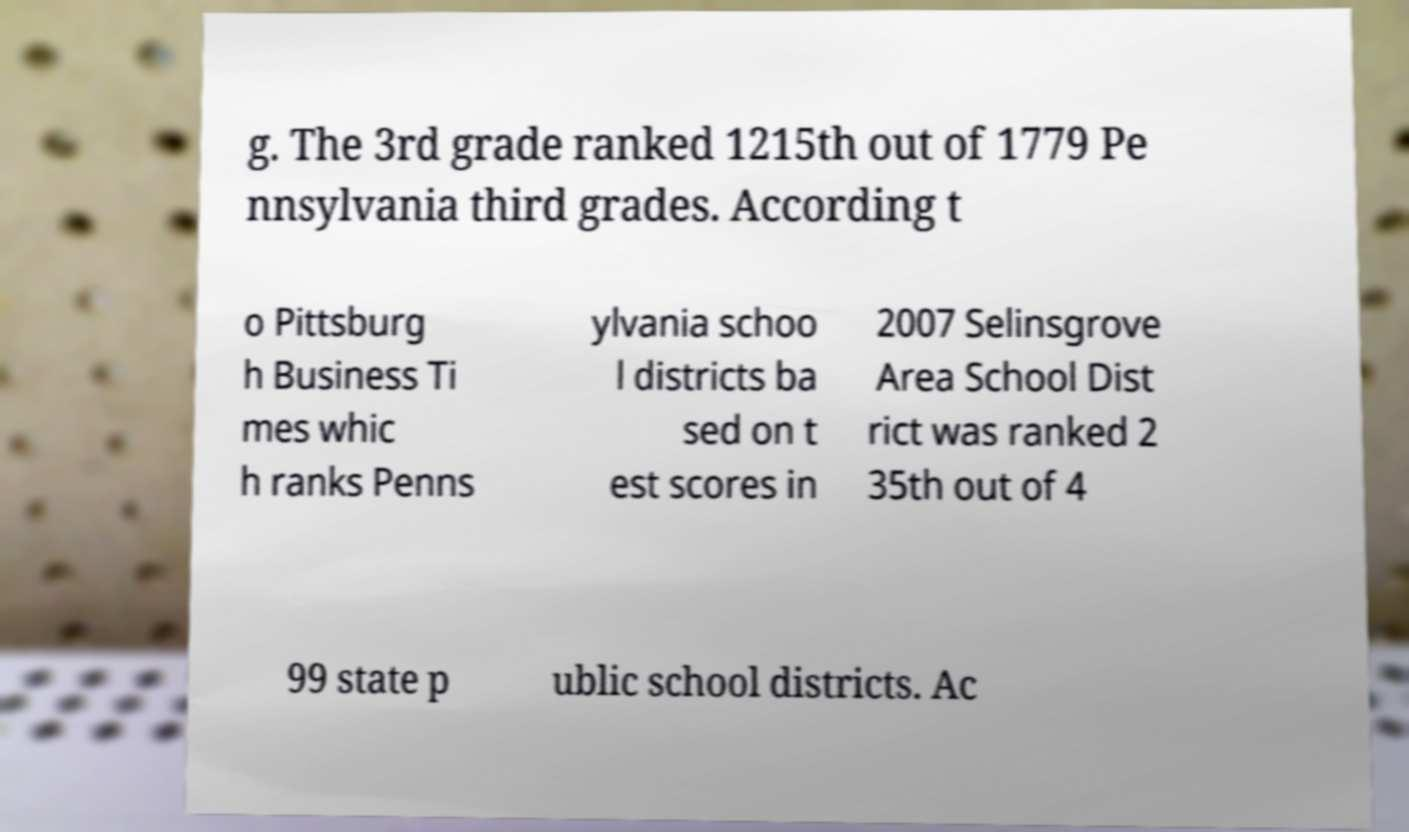Can you accurately transcribe the text from the provided image for me? g. The 3rd grade ranked 1215th out of 1779 Pe nnsylvania third grades. According t o Pittsburg h Business Ti mes whic h ranks Penns ylvania schoo l districts ba sed on t est scores in 2007 Selinsgrove Area School Dist rict was ranked 2 35th out of 4 99 state p ublic school districts. Ac 